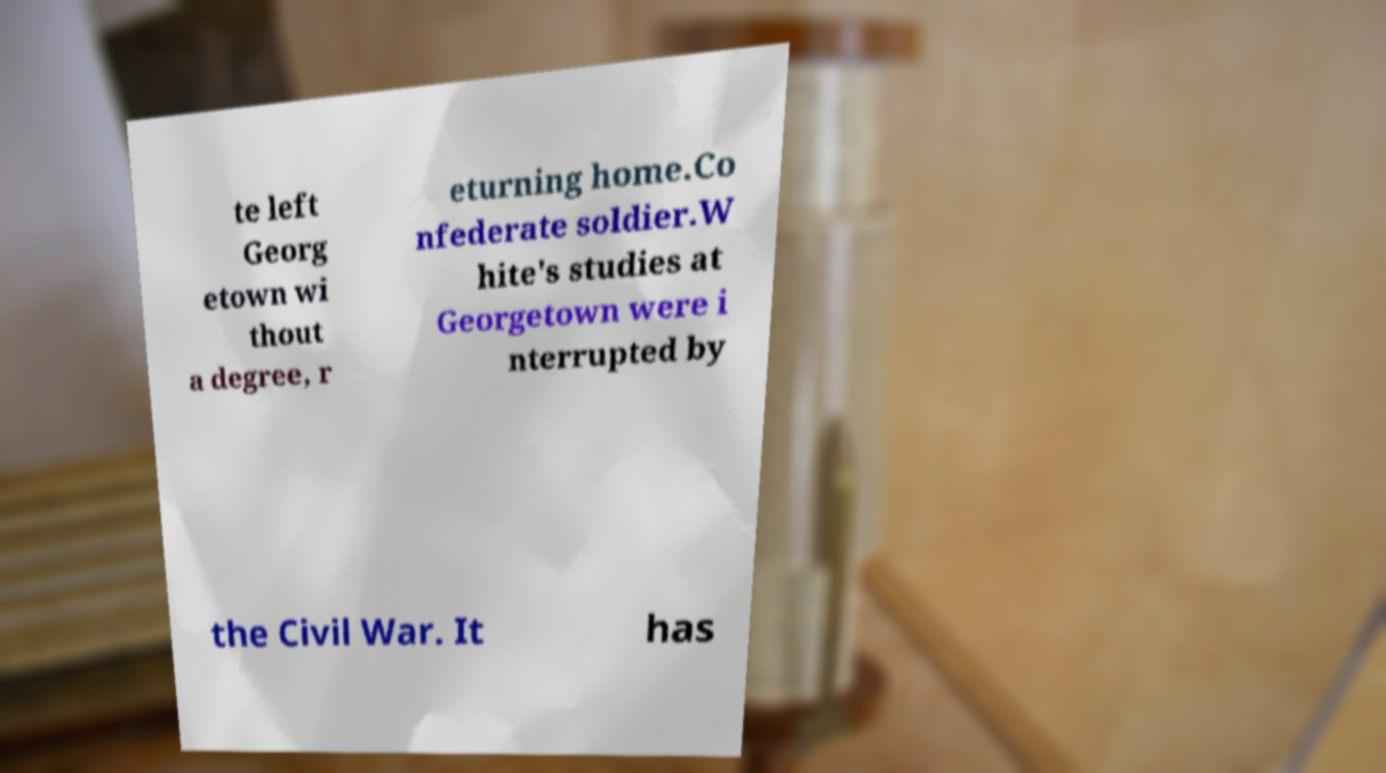There's text embedded in this image that I need extracted. Can you transcribe it verbatim? te left Georg etown wi thout a degree, r eturning home.Co nfederate soldier.W hite's studies at Georgetown were i nterrupted by the Civil War. It has 